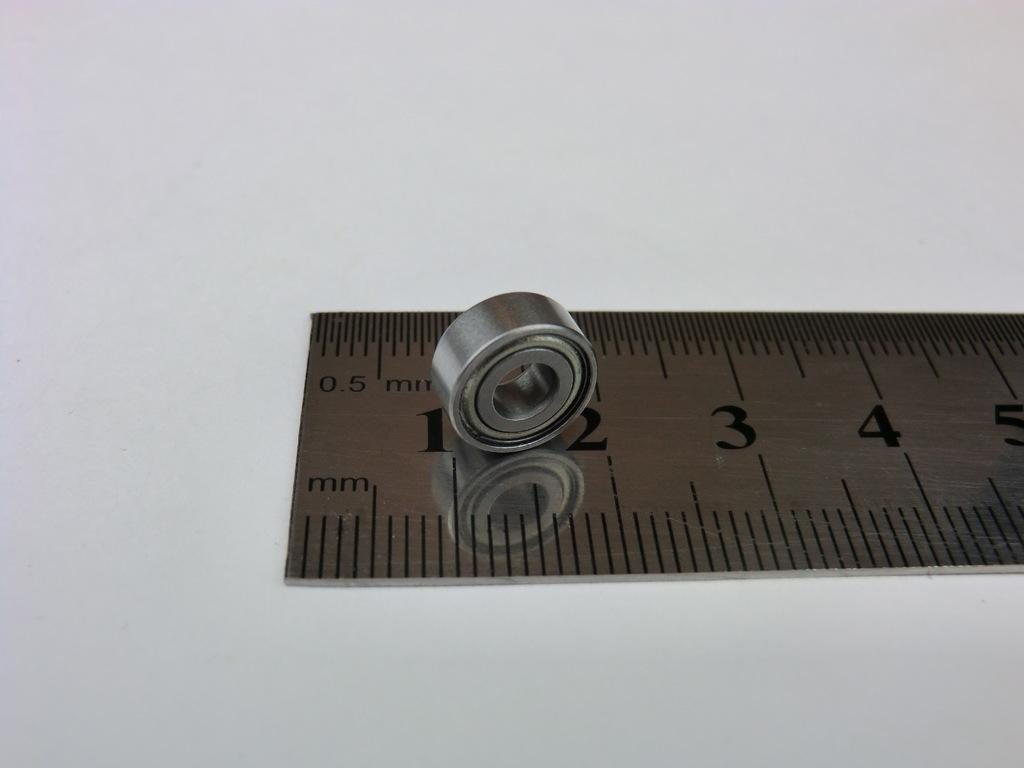<image>
Share a concise interpretation of the image provided. A small bearing placed on the steel rule in between the number 1 and 2 in mm side. 